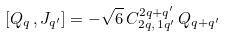Convert formula to latex. <formula><loc_0><loc_0><loc_500><loc_500>[ { Q } _ { q } \, , J _ { q ^ { \prime } } ] = - \sqrt { 6 } \, C _ { 2 q , \, 1 q ^ { \prime } } ^ { 2 q + q ^ { \prime } } \, { Q } _ { q + q ^ { \prime } } \,</formula> 